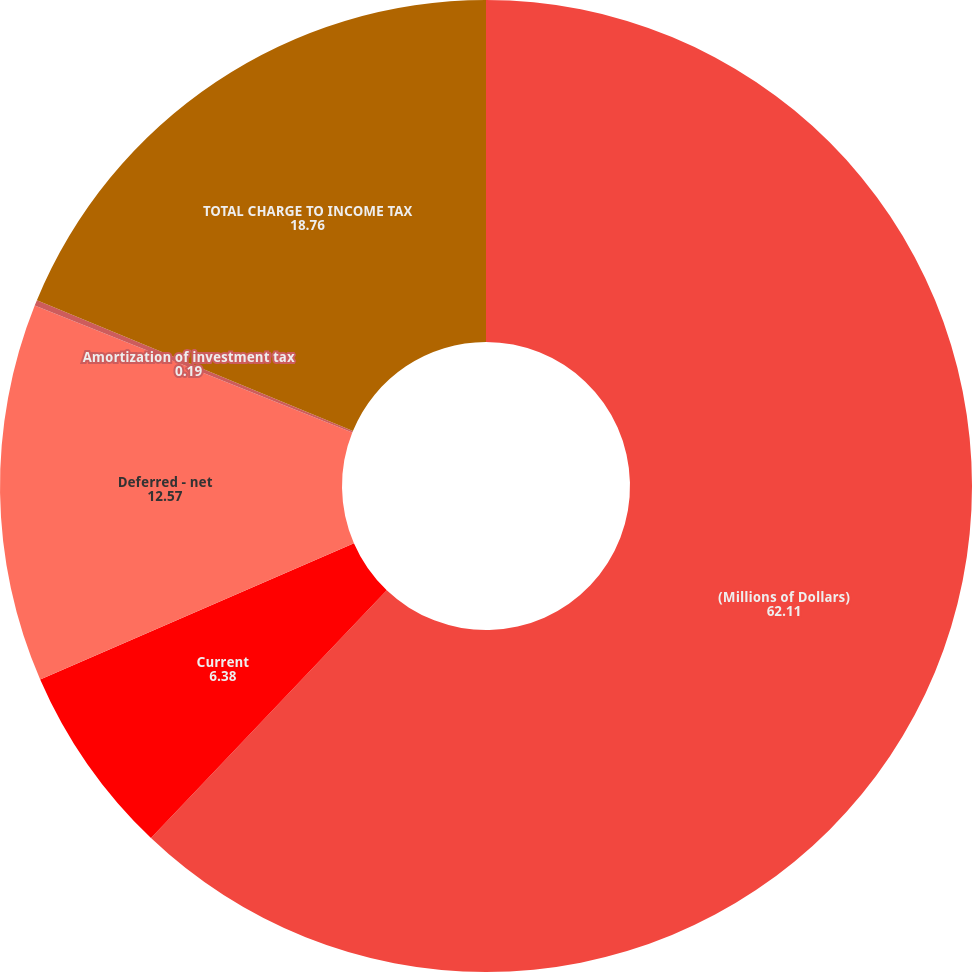<chart> <loc_0><loc_0><loc_500><loc_500><pie_chart><fcel>(Millions of Dollars)<fcel>Current<fcel>Deferred - net<fcel>Amortization of investment tax<fcel>TOTAL CHARGE TO INCOME TAX<nl><fcel>62.11%<fcel>6.38%<fcel>12.57%<fcel>0.19%<fcel>18.76%<nl></chart> 